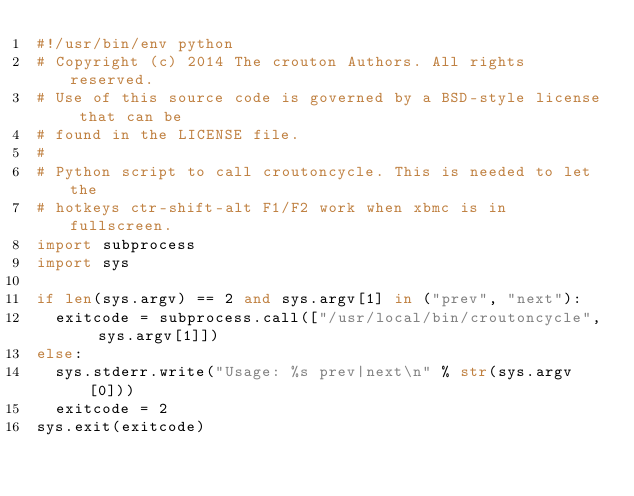<code> <loc_0><loc_0><loc_500><loc_500><_Python_>#!/usr/bin/env python
# Copyright (c) 2014 The crouton Authors. All rights reserved.
# Use of this source code is governed by a BSD-style license that can be
# found in the LICENSE file.
#
# Python script to call croutoncycle. This is needed to let the 
# hotkeys ctr-shift-alt F1/F2 work when xbmc is in fullscreen.
import subprocess
import sys

if len(sys.argv) == 2 and sys.argv[1] in ("prev", "next"):
  exitcode = subprocess.call(["/usr/local/bin/croutoncycle", sys.argv[1]])
else:
  sys.stderr.write("Usage: %s prev|next\n" % str(sys.argv[0]))
  exitcode = 2
sys.exit(exitcode)
</code> 